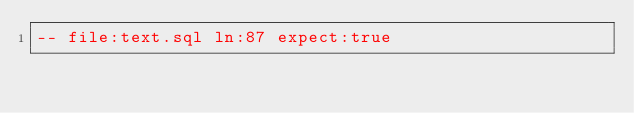<code> <loc_0><loc_0><loc_500><loc_500><_SQL_>-- file:text.sql ln:87 expect:true</code> 